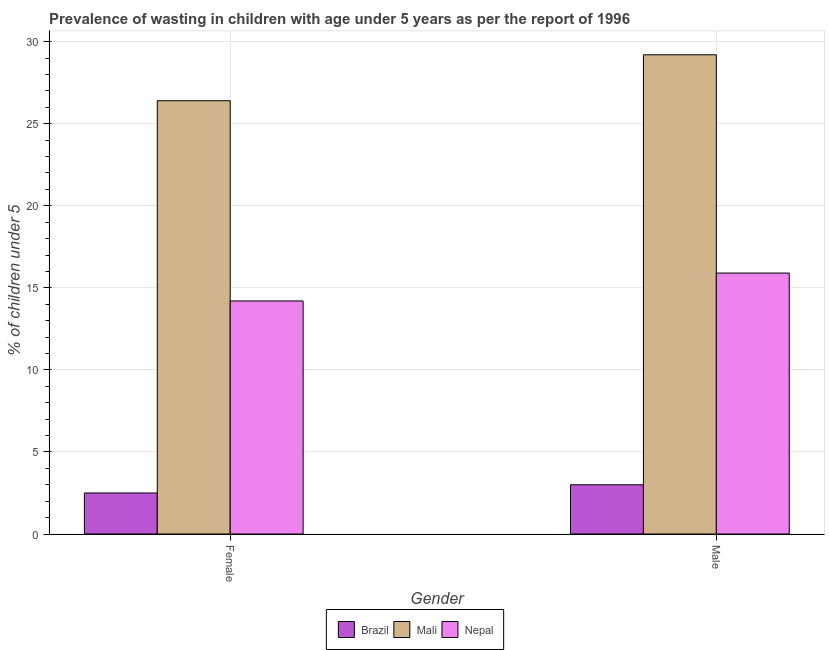How many different coloured bars are there?
Make the answer very short. 3. How many groups of bars are there?
Offer a very short reply. 2. How many bars are there on the 1st tick from the right?
Your answer should be very brief. 3. What is the label of the 2nd group of bars from the left?
Ensure brevity in your answer.  Male. What is the percentage of undernourished male children in Nepal?
Your answer should be very brief. 15.9. Across all countries, what is the maximum percentage of undernourished female children?
Make the answer very short. 26.4. Across all countries, what is the minimum percentage of undernourished female children?
Give a very brief answer. 2.5. In which country was the percentage of undernourished female children maximum?
Your response must be concise. Mali. What is the total percentage of undernourished female children in the graph?
Offer a very short reply. 43.1. What is the difference between the percentage of undernourished female children in Brazil and that in Mali?
Keep it short and to the point. -23.9. What is the difference between the percentage of undernourished female children in Mali and the percentage of undernourished male children in Brazil?
Your answer should be compact. 23.4. What is the average percentage of undernourished female children per country?
Offer a very short reply. 14.37. What is the difference between the percentage of undernourished female children and percentage of undernourished male children in Mali?
Provide a succinct answer. -2.8. In how many countries, is the percentage of undernourished male children greater than 10 %?
Give a very brief answer. 2. What is the ratio of the percentage of undernourished female children in Nepal to that in Mali?
Your response must be concise. 0.54. What does the 1st bar from the right in Male represents?
Ensure brevity in your answer.  Nepal. How many bars are there?
Give a very brief answer. 6. Are all the bars in the graph horizontal?
Provide a short and direct response. No. What is the difference between two consecutive major ticks on the Y-axis?
Ensure brevity in your answer.  5. Does the graph contain any zero values?
Ensure brevity in your answer.  No. Does the graph contain grids?
Offer a very short reply. Yes. How many legend labels are there?
Give a very brief answer. 3. How are the legend labels stacked?
Provide a short and direct response. Horizontal. What is the title of the graph?
Provide a succinct answer. Prevalence of wasting in children with age under 5 years as per the report of 1996. Does "Cote d'Ivoire" appear as one of the legend labels in the graph?
Give a very brief answer. No. What is the label or title of the X-axis?
Your answer should be very brief. Gender. What is the label or title of the Y-axis?
Your answer should be compact.  % of children under 5. What is the  % of children under 5 in Mali in Female?
Keep it short and to the point. 26.4. What is the  % of children under 5 in Nepal in Female?
Offer a terse response. 14.2. What is the  % of children under 5 in Mali in Male?
Ensure brevity in your answer.  29.2. What is the  % of children under 5 in Nepal in Male?
Keep it short and to the point. 15.9. Across all Gender, what is the maximum  % of children under 5 of Brazil?
Your answer should be very brief. 3. Across all Gender, what is the maximum  % of children under 5 in Mali?
Ensure brevity in your answer.  29.2. Across all Gender, what is the maximum  % of children under 5 of Nepal?
Give a very brief answer. 15.9. Across all Gender, what is the minimum  % of children under 5 of Brazil?
Make the answer very short. 2.5. Across all Gender, what is the minimum  % of children under 5 in Mali?
Provide a short and direct response. 26.4. Across all Gender, what is the minimum  % of children under 5 in Nepal?
Make the answer very short. 14.2. What is the total  % of children under 5 of Brazil in the graph?
Offer a terse response. 5.5. What is the total  % of children under 5 of Mali in the graph?
Provide a succinct answer. 55.6. What is the total  % of children under 5 in Nepal in the graph?
Make the answer very short. 30.1. What is the difference between the  % of children under 5 of Brazil in Female and the  % of children under 5 of Mali in Male?
Provide a short and direct response. -26.7. What is the difference between the  % of children under 5 of Brazil in Female and the  % of children under 5 of Nepal in Male?
Offer a terse response. -13.4. What is the difference between the  % of children under 5 in Mali in Female and the  % of children under 5 in Nepal in Male?
Offer a very short reply. 10.5. What is the average  % of children under 5 in Brazil per Gender?
Offer a very short reply. 2.75. What is the average  % of children under 5 of Mali per Gender?
Provide a succinct answer. 27.8. What is the average  % of children under 5 of Nepal per Gender?
Keep it short and to the point. 15.05. What is the difference between the  % of children under 5 in Brazil and  % of children under 5 in Mali in Female?
Make the answer very short. -23.9. What is the difference between the  % of children under 5 in Brazil and  % of children under 5 in Nepal in Female?
Give a very brief answer. -11.7. What is the difference between the  % of children under 5 of Mali and  % of children under 5 of Nepal in Female?
Ensure brevity in your answer.  12.2. What is the difference between the  % of children under 5 of Brazil and  % of children under 5 of Mali in Male?
Ensure brevity in your answer.  -26.2. What is the ratio of the  % of children under 5 in Brazil in Female to that in Male?
Provide a succinct answer. 0.83. What is the ratio of the  % of children under 5 of Mali in Female to that in Male?
Your response must be concise. 0.9. What is the ratio of the  % of children under 5 of Nepal in Female to that in Male?
Provide a short and direct response. 0.89. What is the difference between the highest and the second highest  % of children under 5 in Nepal?
Provide a succinct answer. 1.7. What is the difference between the highest and the lowest  % of children under 5 of Brazil?
Make the answer very short. 0.5. 